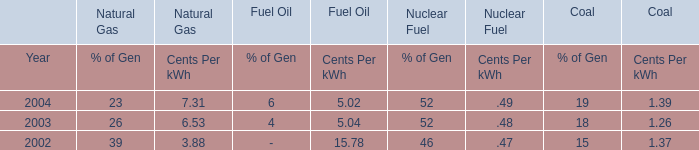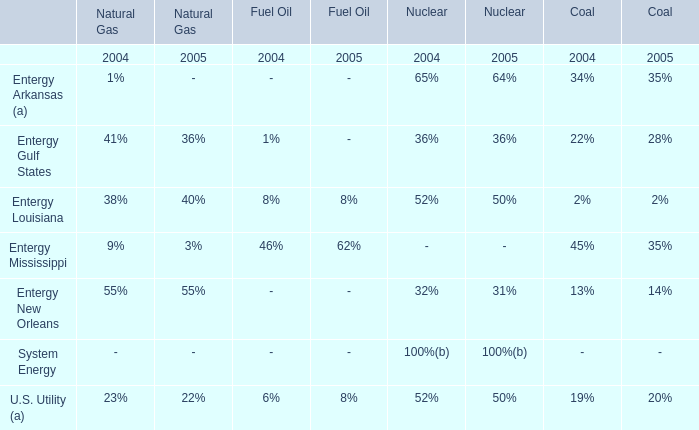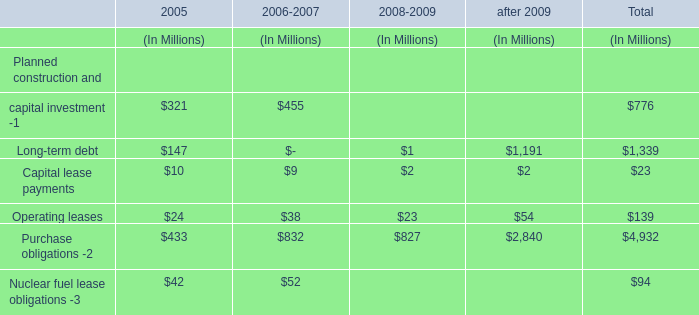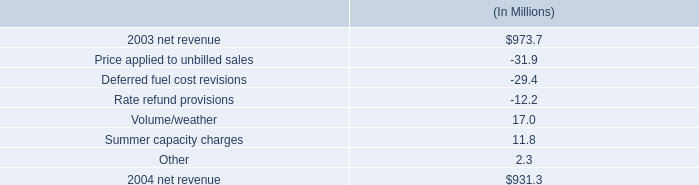what are the deferred fuel cost revisions as a percentage of 2004 net revenue? 
Computations: (-29.4 / 931.3)
Answer: -0.03157. 